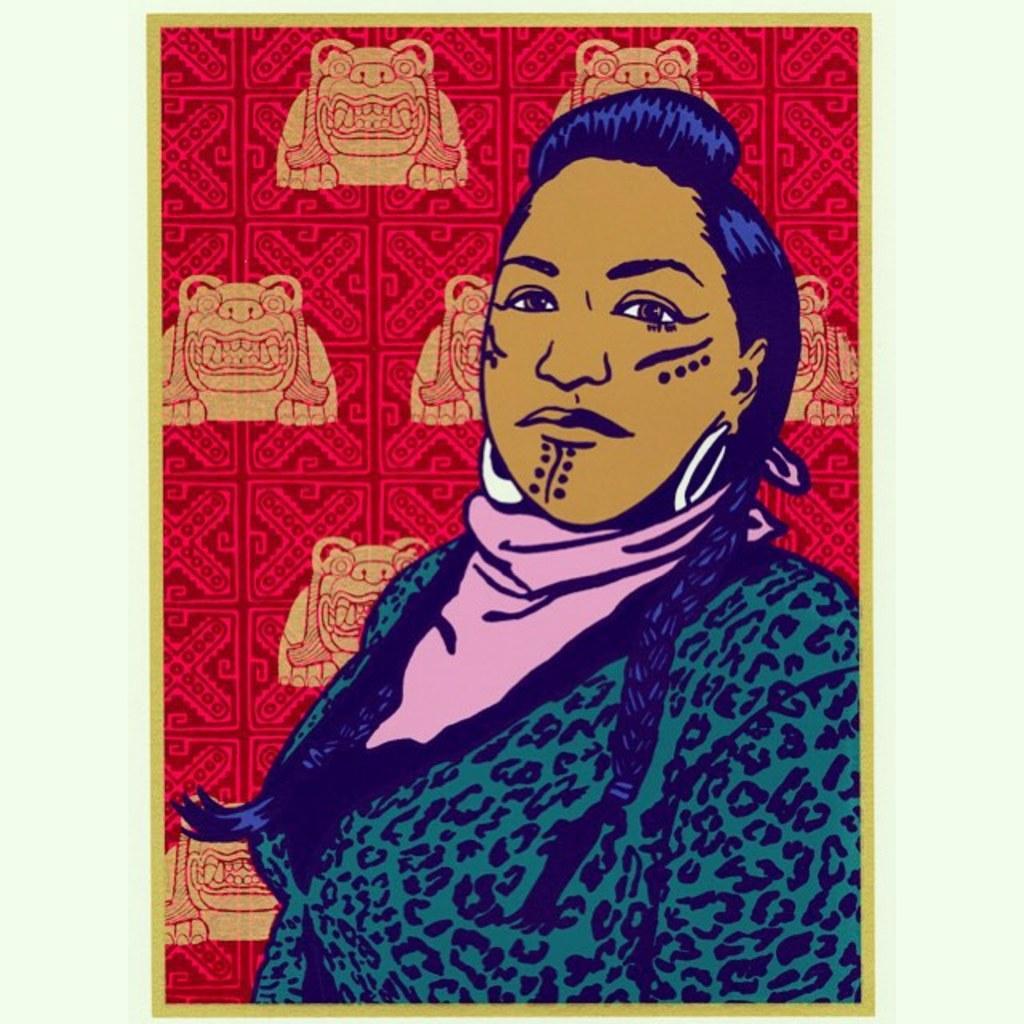How would you summarize this image in a sentence or two? In this image there is a painting, there is a person truncated towards the right of the image, there is a red colored cloth, there are animals on the cloth, the background of the image is white in color. 